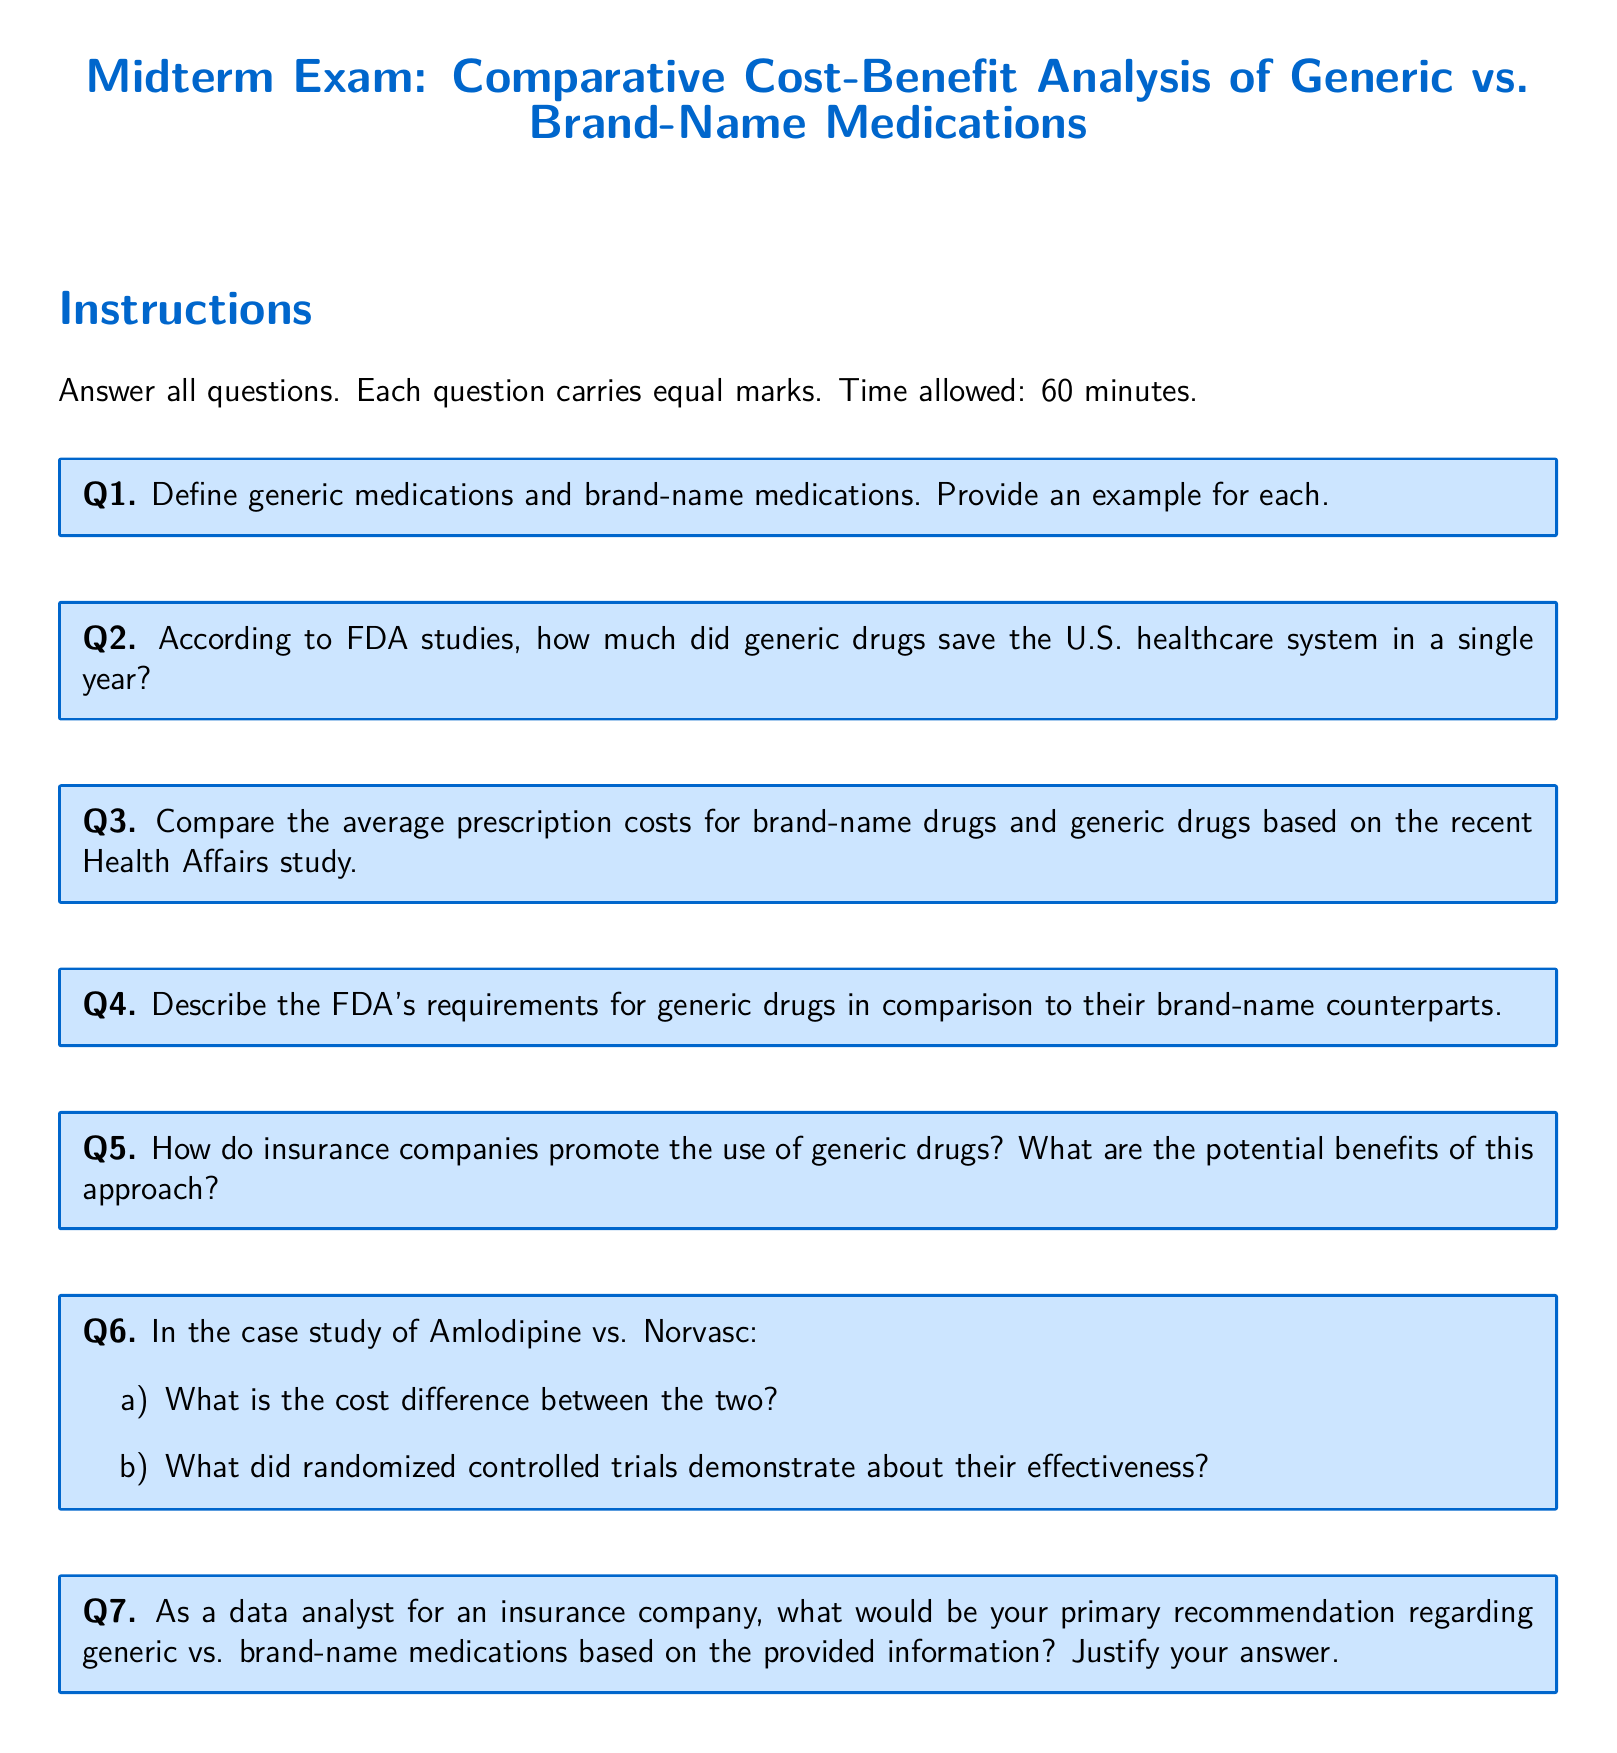What defines generic medications? Generic medications are defined in the document, and an example is requested in the same query.
Answer: Generic medications What is an example of a brand-name medication? The document asks to provide an example of a brand-name medication as part of the definition.
Answer: Norvasc How much did generic drugs save the U.S. healthcare system? The document contains information regarding the total savings by generic drugs in a specific year, as stated in FDA studies.
Answer: Not specified What are the average prescription costs for brand-name drugs? The question relates to the comparison of costs as per the Health Affairs study mentioned in the document.
Answer: Not specified What are FDA's requirements for generic drugs? The document contrasts the FDA requirements for generic drugs versus brand-name medications.
Answer: Not specified How do insurance companies promote generic drugs? The document asks about the strategies insurance companies use to promote the use of generic drugs.
Answer: Not specified What is the cost difference in the case study of Amlodipine vs. Norvasc? The question seeks specifics from the case study regarding the cost of the two medications.
Answer: Not specified What did randomized controlled trials demonstrate regarding Amlodipine and Norvasc? The document refers to the findings from trials related to the effectiveness of the two drugs.
Answer: Not specified What is a primary recommendation regarding generic vs. brand-name medications? As a data analyst, the document prompts for recommendations based on the provided information.
Answer: Not specified 